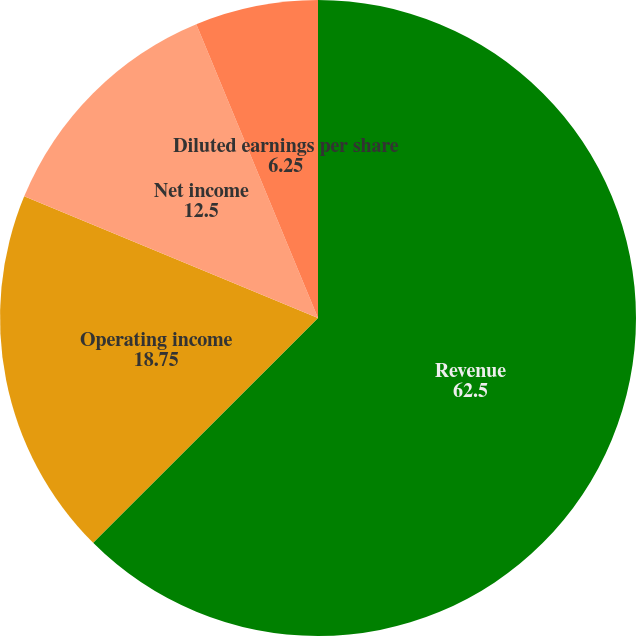<chart> <loc_0><loc_0><loc_500><loc_500><pie_chart><fcel>Revenue<fcel>Operating income<fcel>Net income<fcel>Basic earnings per share<fcel>Diluted earnings per share<nl><fcel>62.5%<fcel>18.75%<fcel>12.5%<fcel>0.0%<fcel>6.25%<nl></chart> 